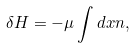<formula> <loc_0><loc_0><loc_500><loc_500>\delta H = - \mu \int d x n ,</formula> 